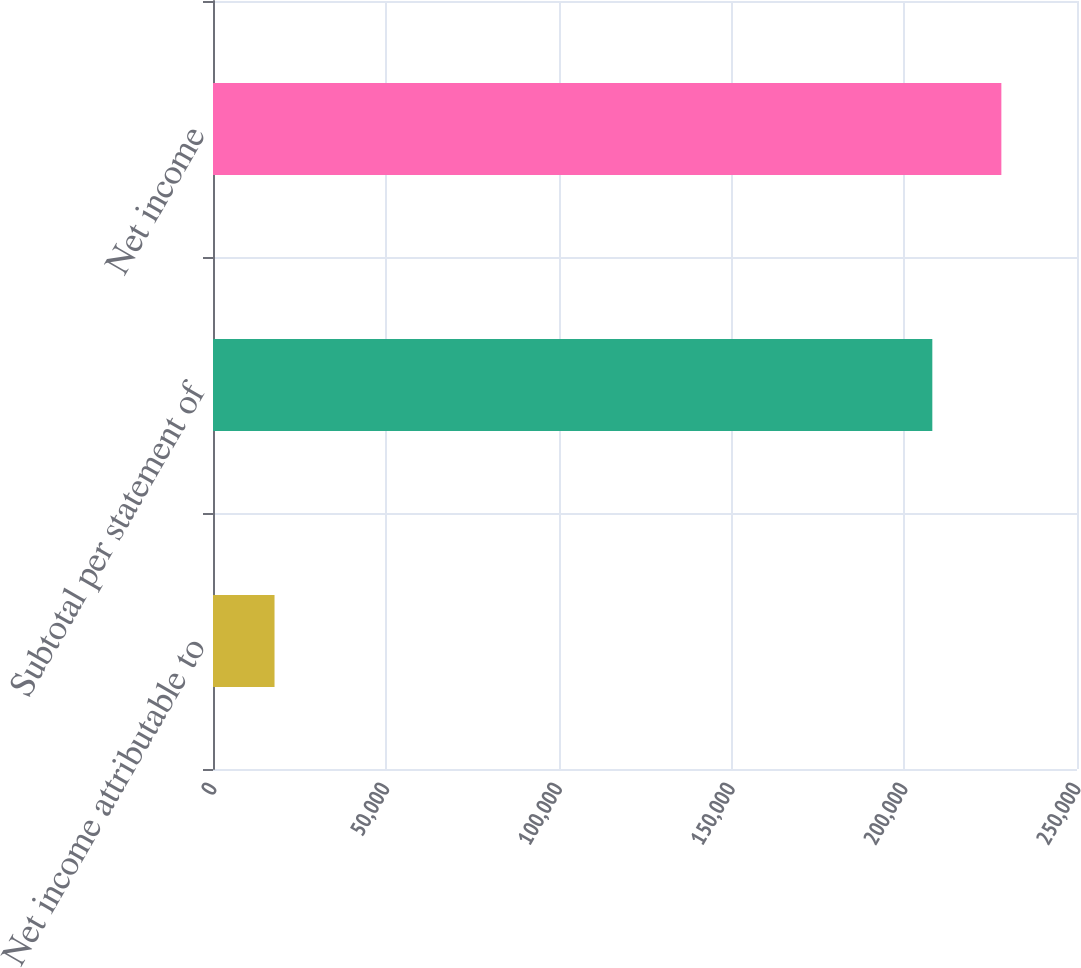Convert chart. <chart><loc_0><loc_0><loc_500><loc_500><bar_chart><fcel>Net income attributable to<fcel>Subtotal per statement of<fcel>Net income<nl><fcel>17804<fcel>208137<fcel>228113<nl></chart> 